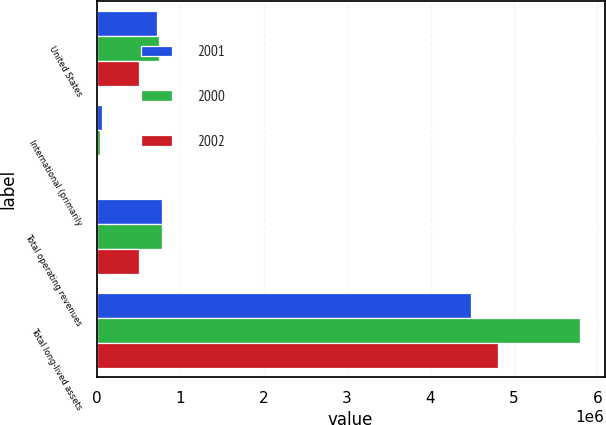Convert chart to OTSL. <chart><loc_0><loc_0><loc_500><loc_500><stacked_bar_chart><ecel><fcel>United States<fcel>International (primarily<fcel>Total operating revenues<fcel>Total long-lived assets<nl><fcel>2001<fcel>723423<fcel>64997<fcel>788420<fcel>4.48039e+06<nl><fcel>2000<fcel>744486<fcel>40664<fcel>785150<fcel>5.79548e+06<nl><fcel>2002<fcel>503800<fcel>6114<fcel>509914<fcel>4.80235e+06<nl></chart> 